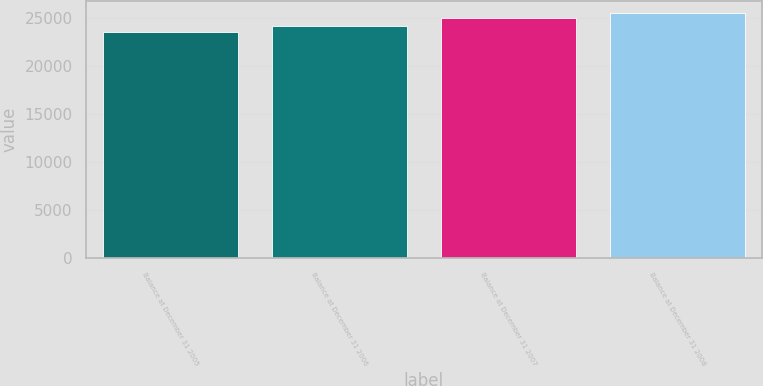<chart> <loc_0><loc_0><loc_500><loc_500><bar_chart><fcel>Balance at December 31 2005<fcel>Balance at December 31 2006<fcel>Balance at December 31 2007<fcel>Balance at December 31 2008<nl><fcel>23561<fcel>24155<fcel>24976<fcel>25527<nl></chart> 